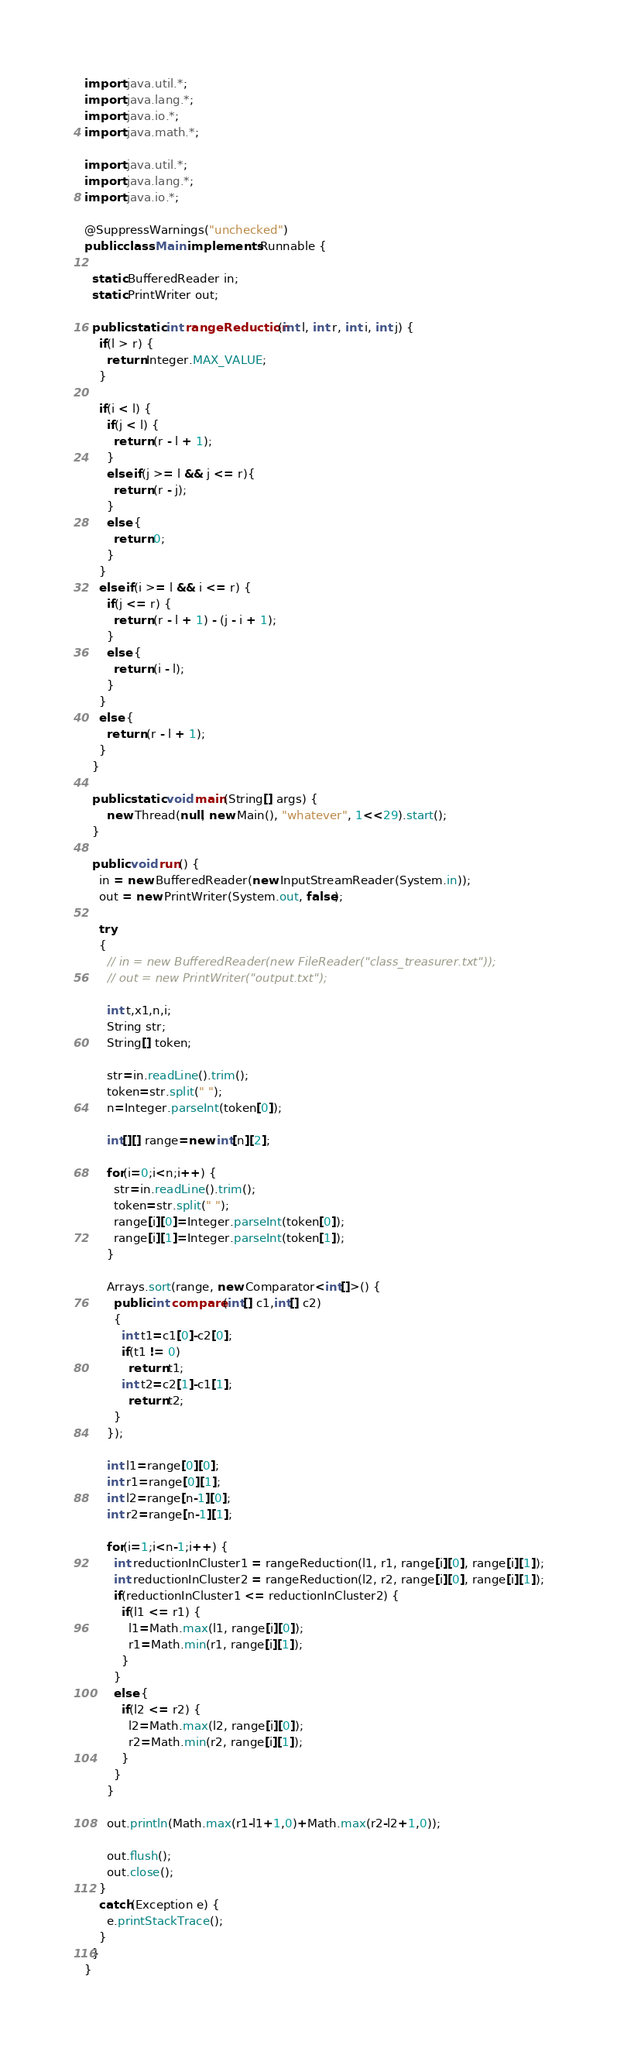Convert code to text. <code><loc_0><loc_0><loc_500><loc_500><_Java_>import java.util.*;
import java.lang.*;
import java.io.*;
import java.math.*;
 
import java.util.*;
import java.lang.*;
import java.io.*;

@SuppressWarnings("unchecked")
public class Main implements Runnable {

  static BufferedReader in;
  static PrintWriter out;

  public static int rangeReduction(int l, int r, int i, int j) {
    if(l > r) {
      return Integer.MAX_VALUE;
    }
    
    if(i < l) {
      if(j < l) {
        return (r - l + 1);
      }
      else if(j >= l && j <= r){
        return (r - j);
      }
      else {
        return 0;
      }
    }
    else if(i >= l && i <= r) {
      if(j <= r) {
        return (r - l + 1) - (j - i + 1);
      }
      else {
        return (i - l);
      }
    }
    else {
      return (r - l + 1);
    }
  }
 
  public static void main(String[] args) {
      new Thread(null, new Main(), "whatever", 1<<29).start();
  }
 
  public void run() {
    in = new BufferedReader(new InputStreamReader(System.in));
    out = new PrintWriter(System.out, false);
 
    try
    {
      // in = new BufferedReader(new FileReader("class_treasurer.txt"));
      // out = new PrintWriter("output.txt");

      int t,x1,n,i;
      String str;
      String[] token;

      str=in.readLine().trim();
      token=str.split(" ");
      n=Integer.parseInt(token[0]);

      int[][] range=new int[n][2];

      for(i=0;i<n;i++) {
        str=in.readLine().trim();
        token=str.split(" ");
        range[i][0]=Integer.parseInt(token[0]);
        range[i][1]=Integer.parseInt(token[1]);
      }

      Arrays.sort(range, new Comparator<int[]>() {
        public int compare(int[] c1,int[] c2)
        {
          int t1=c1[0]-c2[0];
          if(t1 != 0)
            return t1;
          int t2=c2[1]-c1[1];
            return t2;
        }
      });

      int l1=range[0][0];
      int r1=range[0][1];
      int l2=range[n-1][0];
      int r2=range[n-1][1];

      for(i=1;i<n-1;i++) {
        int reductionInCluster1 = rangeReduction(l1, r1, range[i][0], range[i][1]);
        int reductionInCluster2 = rangeReduction(l2, r2, range[i][0], range[i][1]);
        if(reductionInCluster1 <= reductionInCluster2) {
          if(l1 <= r1) {
            l1=Math.max(l1, range[i][0]);
            r1=Math.min(r1, range[i][1]);
          }
        }
        else {
          if(l2 <= r2) {
            l2=Math.max(l2, range[i][0]);
            r2=Math.min(r2, range[i][1]);
          }
        }
      }

      out.println(Math.max(r1-l1+1,0)+Math.max(r2-l2+1,0));

      out.flush();
      out.close();
    }
    catch(Exception e) {
      e.printStackTrace();
    }
  }
}
</code> 